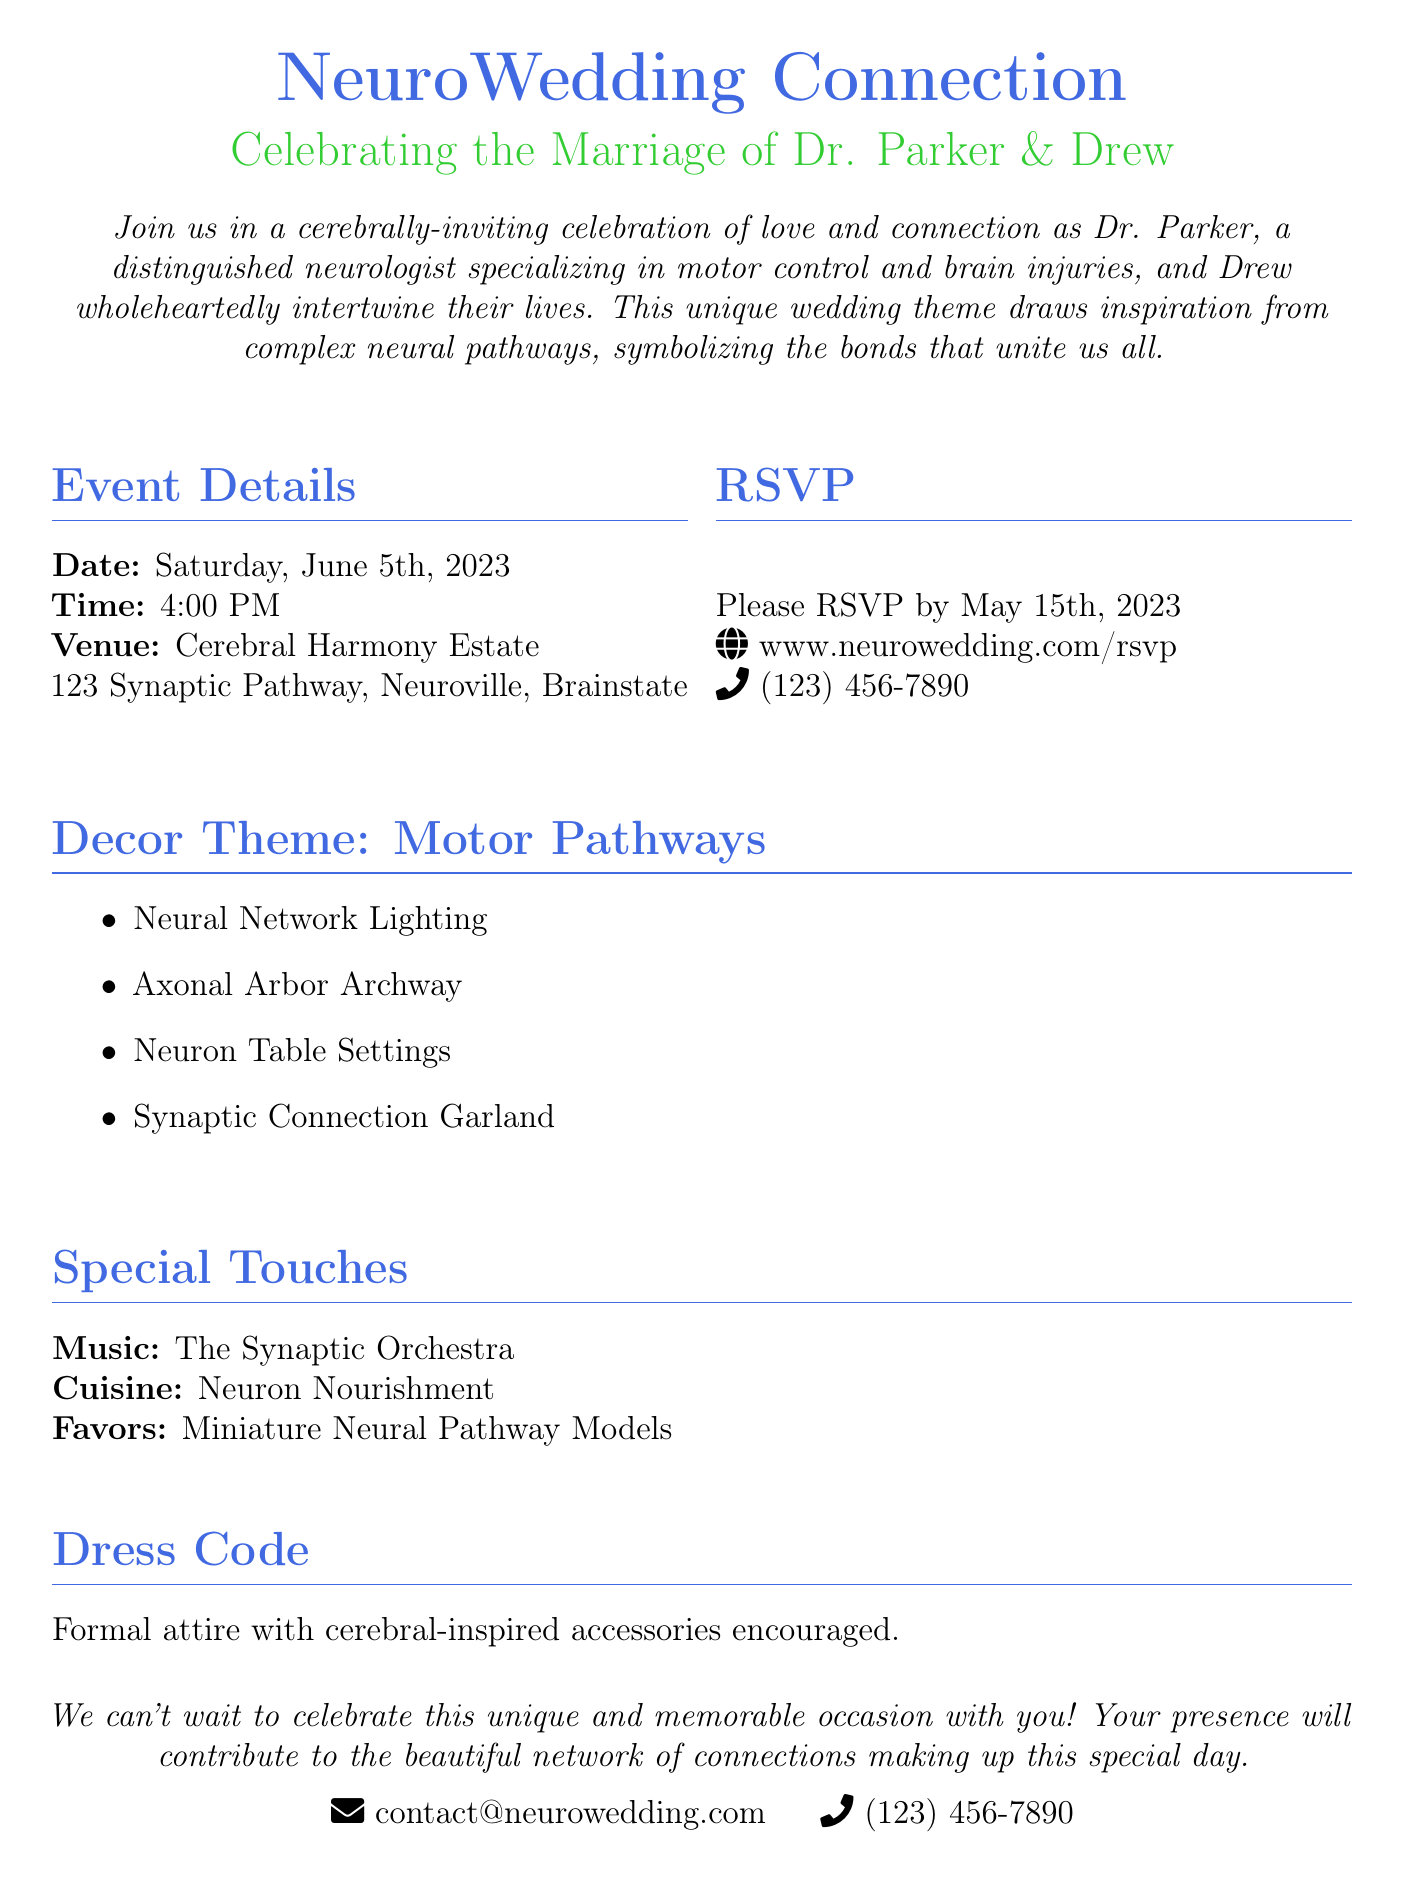What is the date of the wedding? The date of the wedding is explicitly stated in the document as Saturday, June 5th, 2023.
Answer: Saturday, June 5th, 2023 What is the venue name? The venue name given in the document is Cerebral Harmony Estate.
Answer: Cerebral Harmony Estate What time does the wedding start? The document specifies that the wedding starts at 4:00 PM.
Answer: 4:00 PM What theme is the wedding decor inspired by? The wedding decor theme is inspired by motor pathways, as mentioned in the document.
Answer: Motor pathways What does the dress code entail? The dress code is described as formal attire with cerebral-inspired accessories encouraged.
Answer: Formal attire with cerebral-inspired accessories How can guests RSVP? Guests can RSVP by visiting the website provided in the document or calling the phone number.
Answer: www.neurowedding.com/rsvp What is the special touch related to music? The document states that the music will be provided by The Synaptic Orchestra.
Answer: The Synaptic Orchestra What is one of the wedding favors? One of the wedding favors mentioned is miniature neural pathway models.
Answer: Miniature Neural Pathway Models How should guests contact for more information? The document includes contact information with an email and phone number for guests to reach out for more details.
Answer: contact@neurowedding.com 